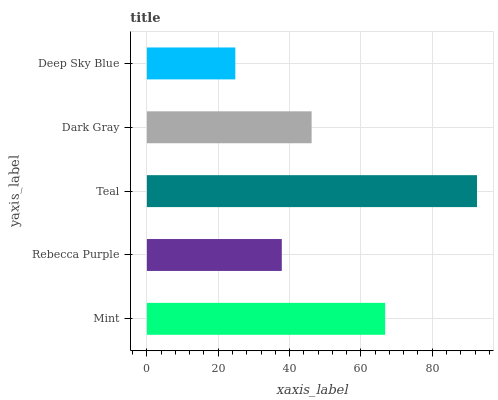Is Deep Sky Blue the minimum?
Answer yes or no. Yes. Is Teal the maximum?
Answer yes or no. Yes. Is Rebecca Purple the minimum?
Answer yes or no. No. Is Rebecca Purple the maximum?
Answer yes or no. No. Is Mint greater than Rebecca Purple?
Answer yes or no. Yes. Is Rebecca Purple less than Mint?
Answer yes or no. Yes. Is Rebecca Purple greater than Mint?
Answer yes or no. No. Is Mint less than Rebecca Purple?
Answer yes or no. No. Is Dark Gray the high median?
Answer yes or no. Yes. Is Dark Gray the low median?
Answer yes or no. Yes. Is Rebecca Purple the high median?
Answer yes or no. No. Is Teal the low median?
Answer yes or no. No. 